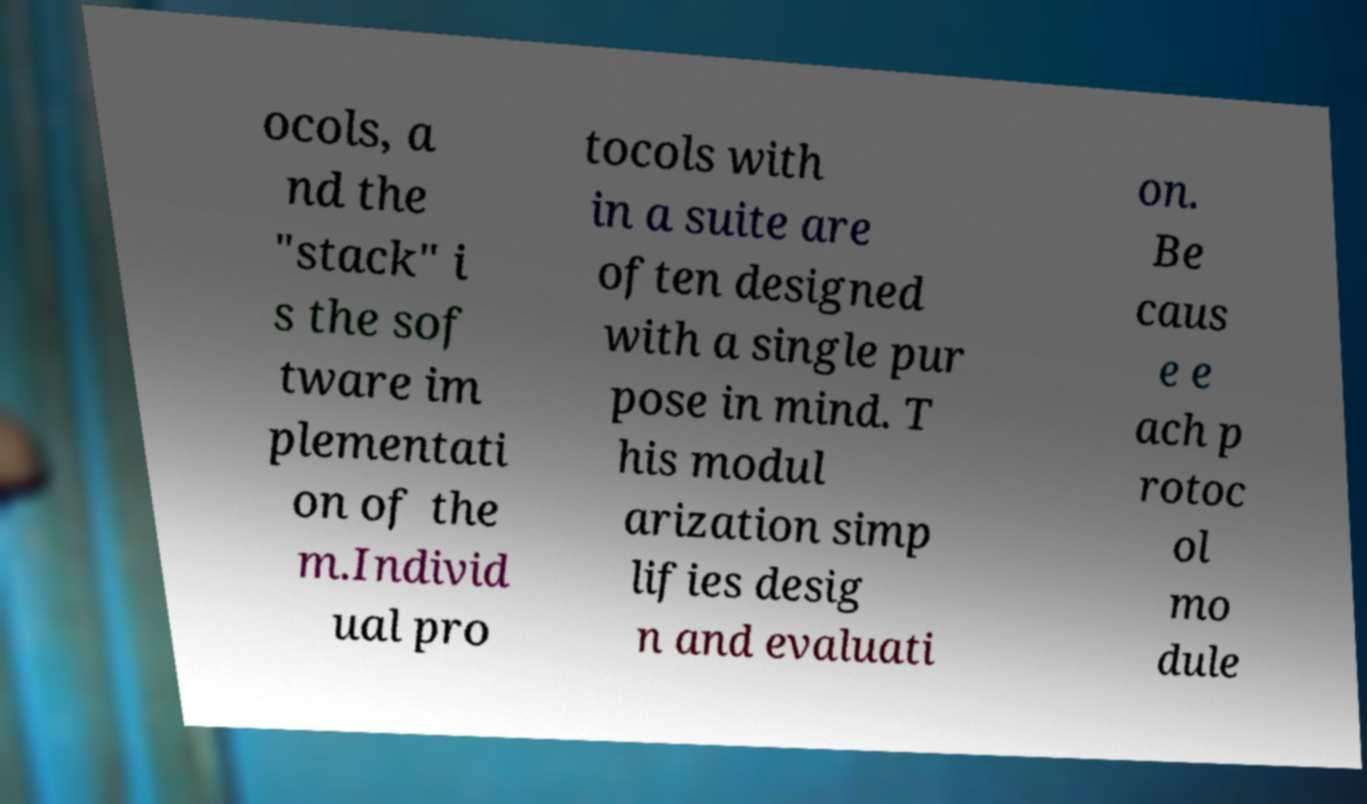What messages or text are displayed in this image? I need them in a readable, typed format. ocols, a nd the "stack" i s the sof tware im plementati on of the m.Individ ual pro tocols with in a suite are often designed with a single pur pose in mind. T his modul arization simp lifies desig n and evaluati on. Be caus e e ach p rotoc ol mo dule 